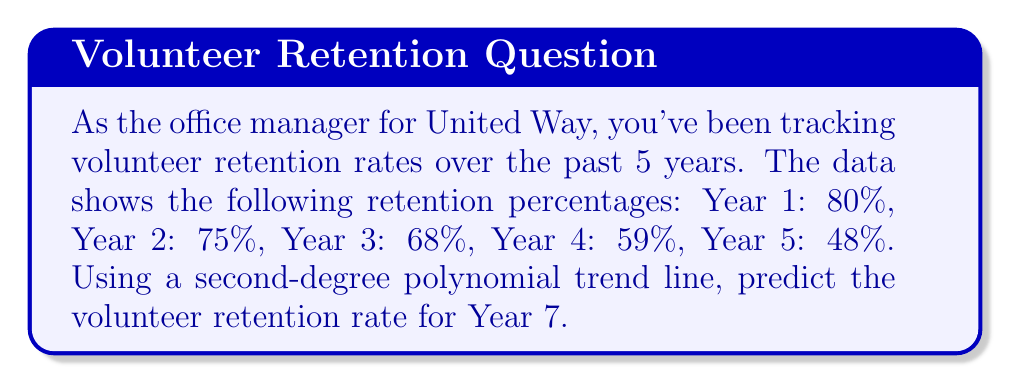Could you help me with this problem? To solve this problem, we'll follow these steps:

1. Define our variables:
   Let $x$ represent the year number and $y$ represent the retention rate.

2. Plot the given data points:
   $(1, 80)$, $(2, 75)$, $(3, 68)$, $(4, 59)$, $(5, 48)$

3. Use a second-degree polynomial equation:
   $y = ax^2 + bx + c$

4. Use a polynomial regression calculator or spreadsheet software to find the coefficients $a$, $b$, and $c$. The resulting equation is:
   $y = 1.4x^2 - 15.6x + 94.2$

5. To predict Year 7, substitute $x = 7$ into the equation:
   $y = 1.4(7)^2 - 15.6(7) + 94.2$
   $y = 1.4(49) - 109.2 + 94.2$
   $y = 68.6 - 109.2 + 94.2$
   $y = 53.6$

6. Round to the nearest whole percentage:
   $53.6\% \approx 54\%$

Therefore, the predicted volunteer retention rate for Year 7 is approximately 54%.
Answer: 54% 